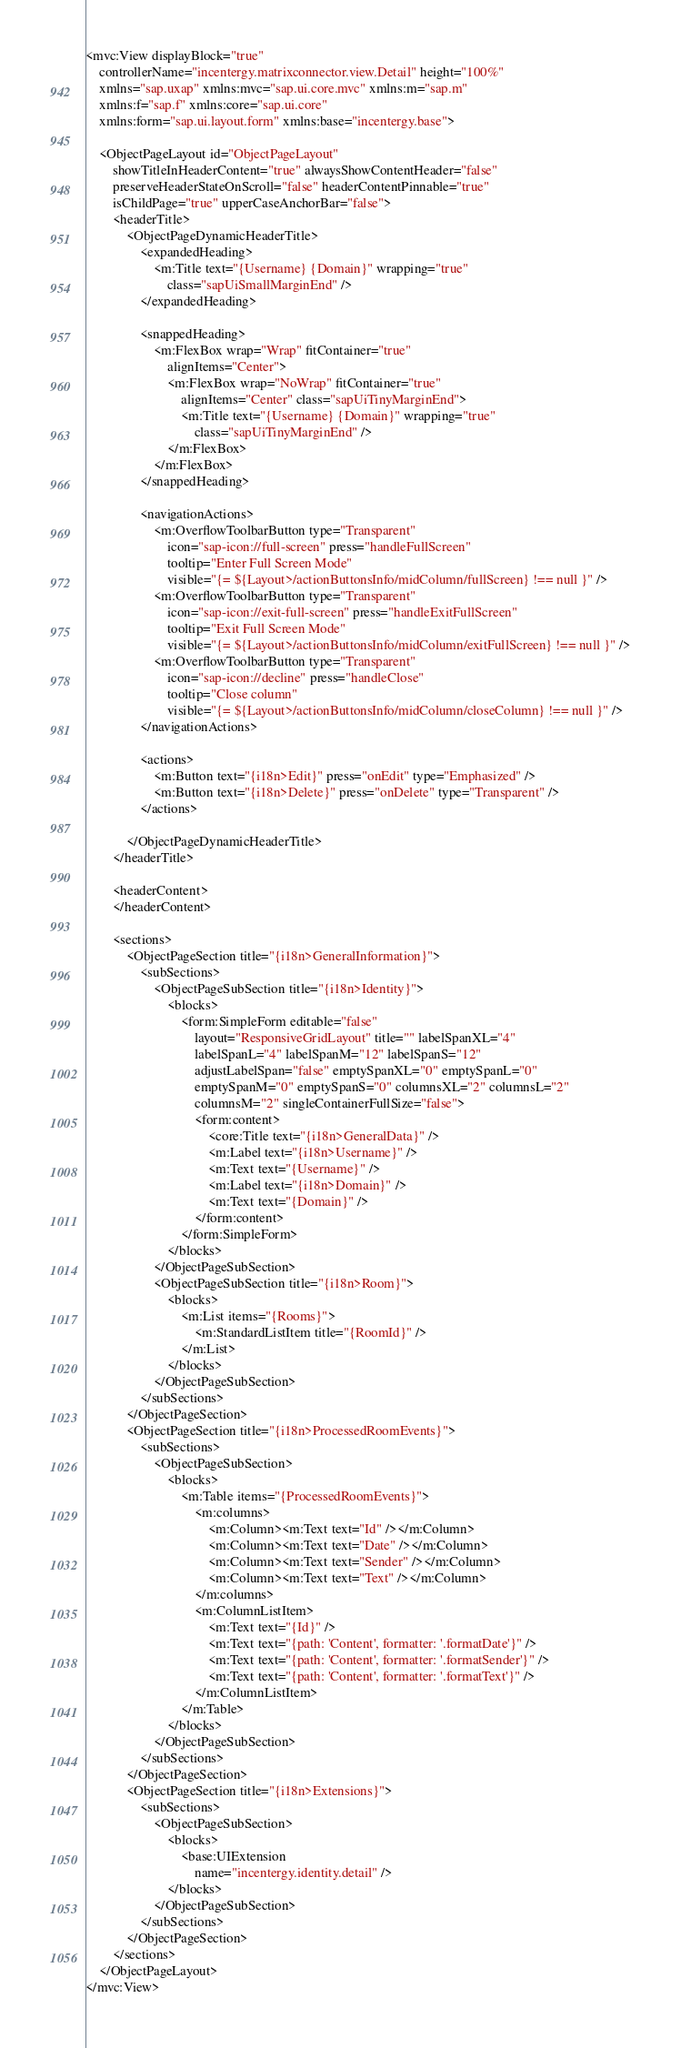Convert code to text. <code><loc_0><loc_0><loc_500><loc_500><_XML_><mvc:View displayBlock="true"
	controllerName="incentergy.matrixconnector.view.Detail" height="100%"
	xmlns="sap.uxap" xmlns:mvc="sap.ui.core.mvc" xmlns:m="sap.m"
	xmlns:f="sap.f" xmlns:core="sap.ui.core"
	xmlns:form="sap.ui.layout.form" xmlns:base="incentergy.base">

	<ObjectPageLayout id="ObjectPageLayout"
		showTitleInHeaderContent="true" alwaysShowContentHeader="false"
		preserveHeaderStateOnScroll="false" headerContentPinnable="true"
		isChildPage="true" upperCaseAnchorBar="false">
		<headerTitle>
			<ObjectPageDynamicHeaderTitle>
				<expandedHeading>
					<m:Title text="{Username} {Domain}" wrapping="true"
						class="sapUiSmallMarginEnd" />
				</expandedHeading>

				<snappedHeading>
					<m:FlexBox wrap="Wrap" fitContainer="true"
						alignItems="Center">
						<m:FlexBox wrap="NoWrap" fitContainer="true"
							alignItems="Center" class="sapUiTinyMarginEnd">
							<m:Title text="{Username} {Domain}" wrapping="true"
								class="sapUiTinyMarginEnd" />
						</m:FlexBox>
					</m:FlexBox>
				</snappedHeading>

				<navigationActions>
					<m:OverflowToolbarButton type="Transparent"
						icon="sap-icon://full-screen" press="handleFullScreen"
						tooltip="Enter Full Screen Mode"
						visible="{= ${Layout>/actionButtonsInfo/midColumn/fullScreen} !== null }" />
					<m:OverflowToolbarButton type="Transparent"
						icon="sap-icon://exit-full-screen" press="handleExitFullScreen"
						tooltip="Exit Full Screen Mode"
						visible="{= ${Layout>/actionButtonsInfo/midColumn/exitFullScreen} !== null }" />
					<m:OverflowToolbarButton type="Transparent"
						icon="sap-icon://decline" press="handleClose"
						tooltip="Close column"
						visible="{= ${Layout>/actionButtonsInfo/midColumn/closeColumn} !== null }" />
				</navigationActions>

				<actions>
					<m:Button text="{i18n>Edit}" press="onEdit" type="Emphasized" />
					<m:Button text="{i18n>Delete}" press="onDelete" type="Transparent" />
				</actions>

			</ObjectPageDynamicHeaderTitle>
		</headerTitle>

		<headerContent>
		</headerContent>

		<sections>
			<ObjectPageSection title="{i18n>GeneralInformation}">
				<subSections>
					<ObjectPageSubSection title="{i18n>Identity}">
						<blocks>
							<form:SimpleForm editable="false"
								layout="ResponsiveGridLayout" title="" labelSpanXL="4"
								labelSpanL="4" labelSpanM="12" labelSpanS="12"
								adjustLabelSpan="false" emptySpanXL="0" emptySpanL="0"
								emptySpanM="0" emptySpanS="0" columnsXL="2" columnsL="2"
								columnsM="2" singleContainerFullSize="false">
								<form:content>
									<core:Title text="{i18n>GeneralData}" />
									<m:Label text="{i18n>Username}" />
									<m:Text text="{Username}" />
									<m:Label text="{i18n>Domain}" />
									<m:Text text="{Domain}" />
								</form:content>
							</form:SimpleForm>
						</blocks>
					</ObjectPageSubSection>
					<ObjectPageSubSection title="{i18n>Room}">
						<blocks>
							<m:List items="{Rooms}">
								<m:StandardListItem title="{RoomId}" />
							</m:List>
						</blocks>
					</ObjectPageSubSection>
				</subSections>
			</ObjectPageSection>
			<ObjectPageSection title="{i18n>ProcessedRoomEvents}">
				<subSections>
					<ObjectPageSubSection>
						<blocks>
							<m:Table items="{ProcessedRoomEvents}">
								<m:columns>
									<m:Column><m:Text text="Id" /></m:Column>
									<m:Column><m:Text text="Date" /></m:Column>
									<m:Column><m:Text text="Sender" /></m:Column>
									<m:Column><m:Text text="Text" /></m:Column>
								</m:columns>
								<m:ColumnListItem>
									<m:Text text="{Id}" />
									<m:Text text="{path: 'Content', formatter: '.formatDate'}" />
									<m:Text text="{path: 'Content', formatter: '.formatSender'}" />
									<m:Text text="{path: 'Content', formatter: '.formatText'}" />
								</m:ColumnListItem>
							</m:Table>
						</blocks>
					</ObjectPageSubSection>
				</subSections>
			</ObjectPageSection>
			<ObjectPageSection title="{i18n>Extensions}">
				<subSections>
					<ObjectPageSubSection>
						<blocks>
							<base:UIExtension
								name="incentergy.identity.detail" />
						</blocks>
					</ObjectPageSubSection>
				</subSections>
			</ObjectPageSection>
		</sections>
	</ObjectPageLayout>
</mvc:View></code> 